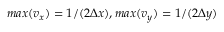<formula> <loc_0><loc_0><loc_500><loc_500>\max ( v _ { x } ) = 1 / ( 2 \Delta x ) , \max ( v _ { y } ) = 1 / ( 2 \Delta y )</formula> 